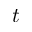<formula> <loc_0><loc_0><loc_500><loc_500>t</formula> 